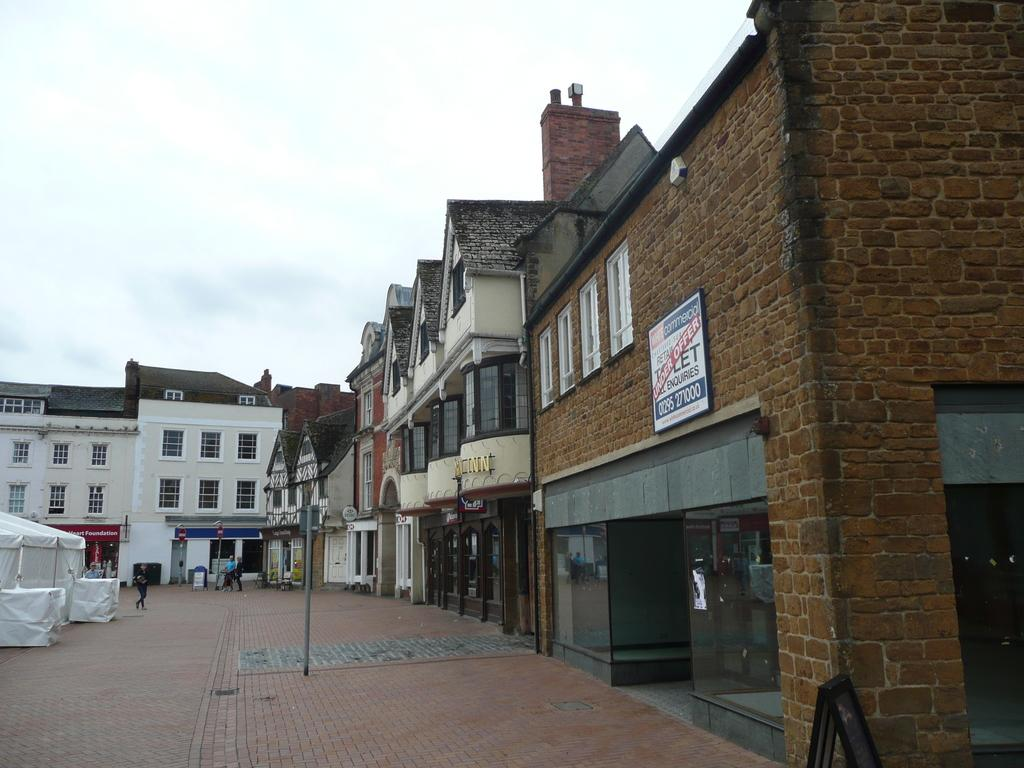What structures are located in the front and on the right side of the image? There are buildings in the front and on the right side of the image. What can be seen on the left side of the image? There is a footpath on the left side of the image. What are some people doing on the footpath? Some persons are walking on the footpath. What is visible above the buildings and footpath? The sky is visible above the buildings and footpath. What type of cord is being used by the secretary in the image? There is no secretary or cord present in the image. 